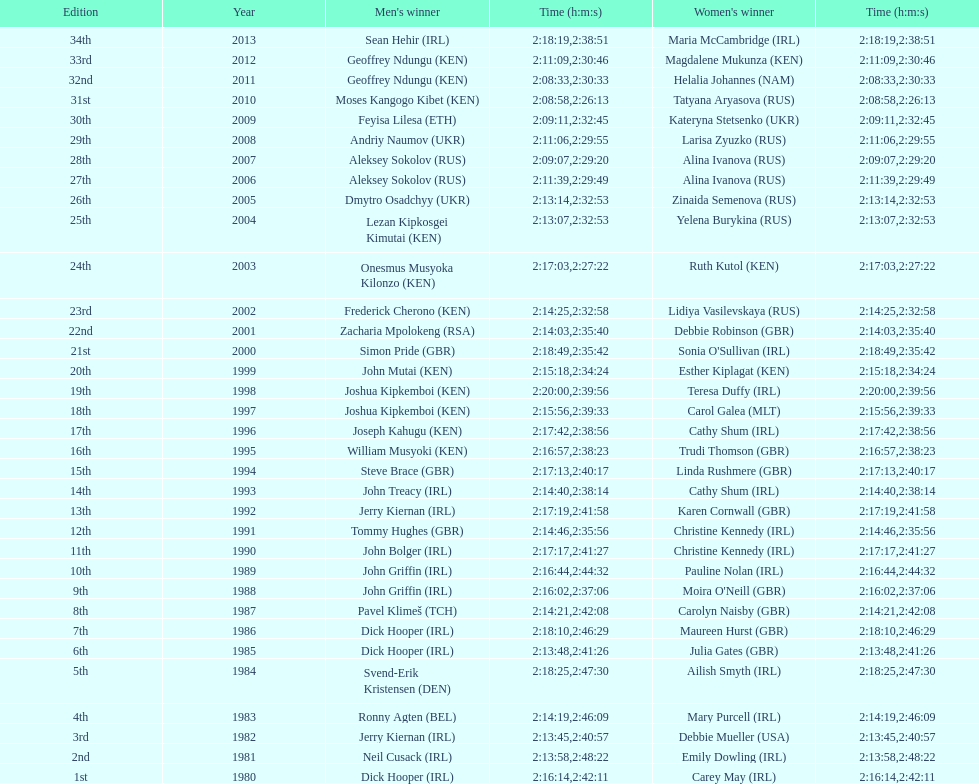Who triumphed following the termination of joseph kipkemboi's consecutive successes? John Mutai (KEN). 